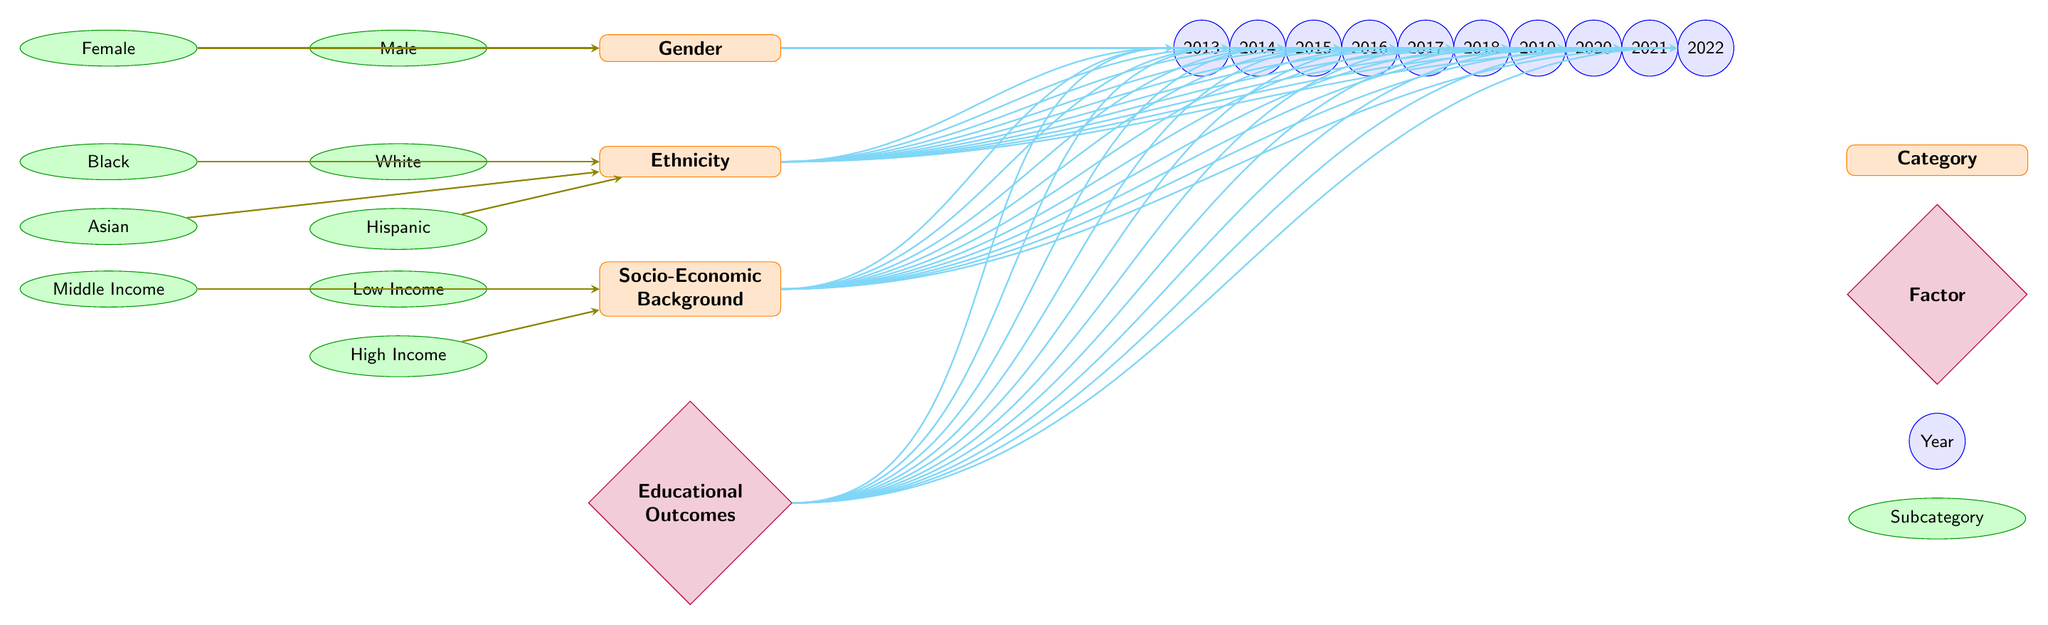What are the main categories represented in the diagram? The diagram explicitly displays three main categories: Gender, Ethnicity, and Socio-Economic Background, which are positioned vertically. These categories serve as the foundation of the analysis in the diagram.
Answer: Gender, Ethnicity, Socio-Economic Background How many years are represented in the diagram? The diagram shows a total of ten years, ranging from 2013 to 2022, which are placed horizontally across the top of the categories.
Answer: 10 What is the subcategory for the lowest socio-economic background? Among the socio-economic subcategories, "Low Income" is identified as the lowest tier and is placed at the left of the socio-economic category.
Answer: Low Income Which subcategory under ethnicity is positioned directly below Black? The subcategory immediately beneath Black is Hispanic, indicating the hierarchy of the ethnic categories represented in the diagram.
Answer: Hispanic How are the educational outcomes connected to the main categories? The educational outcomes are illustrated as a singular category at the bottom, with arrows indicating a connection from the three main categories (Gender, Ethnicity, Socio-Economic Background), illustrating their dependency on these categories.
Answer: With arrows How many subcategories are associated with the Gender category? There are two visible subcategories under the Gender category: Male and Female. These subcategories help detail the diversity within the major category of gender.
Answer: 2 Which year has the most connections to the Gender category? Each year from 2013 to 2022 has an equal number of connections represented by arrows, thus no particular year stands out. However, the response remains consistent with the equal distribution of connections across all years.
Answer: Equal connections What do the cyan arrows indicate in the diagram? The cyan arrows illustrate the connections or dependencies leading from each of the main categories (Gender, Ethnicity, and Socio-Economic Background) to each year represented in the diagram, visually demonstrating the flow of information.
Answer: Connections What is the color and shape of the node representing the Ethnicity category? The Ethnicity category is represented as a rectangle with rounded corners, filled with an orange shade, helping distinguish it clearly from the other categories.
Answer: Rectangle, orange 